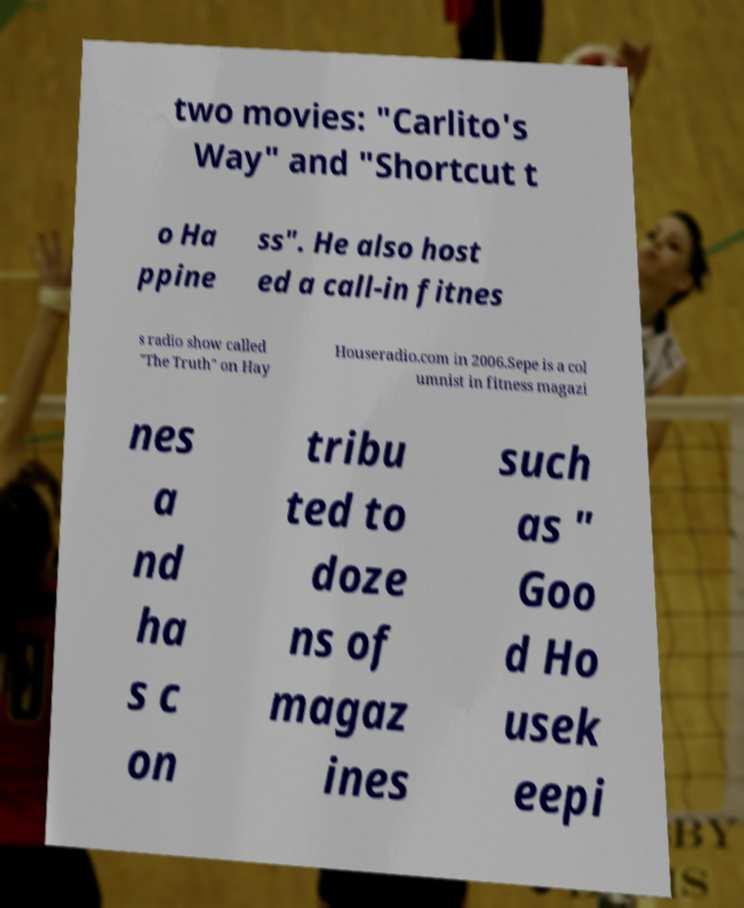I need the written content from this picture converted into text. Can you do that? two movies: "Carlito's Way" and "Shortcut t o Ha ppine ss". He also host ed a call-in fitnes s radio show called "The Truth" on Hay Houseradio.com in 2006.Sepe is a col umnist in fitness magazi nes a nd ha s c on tribu ted to doze ns of magaz ines such as " Goo d Ho usek eepi 